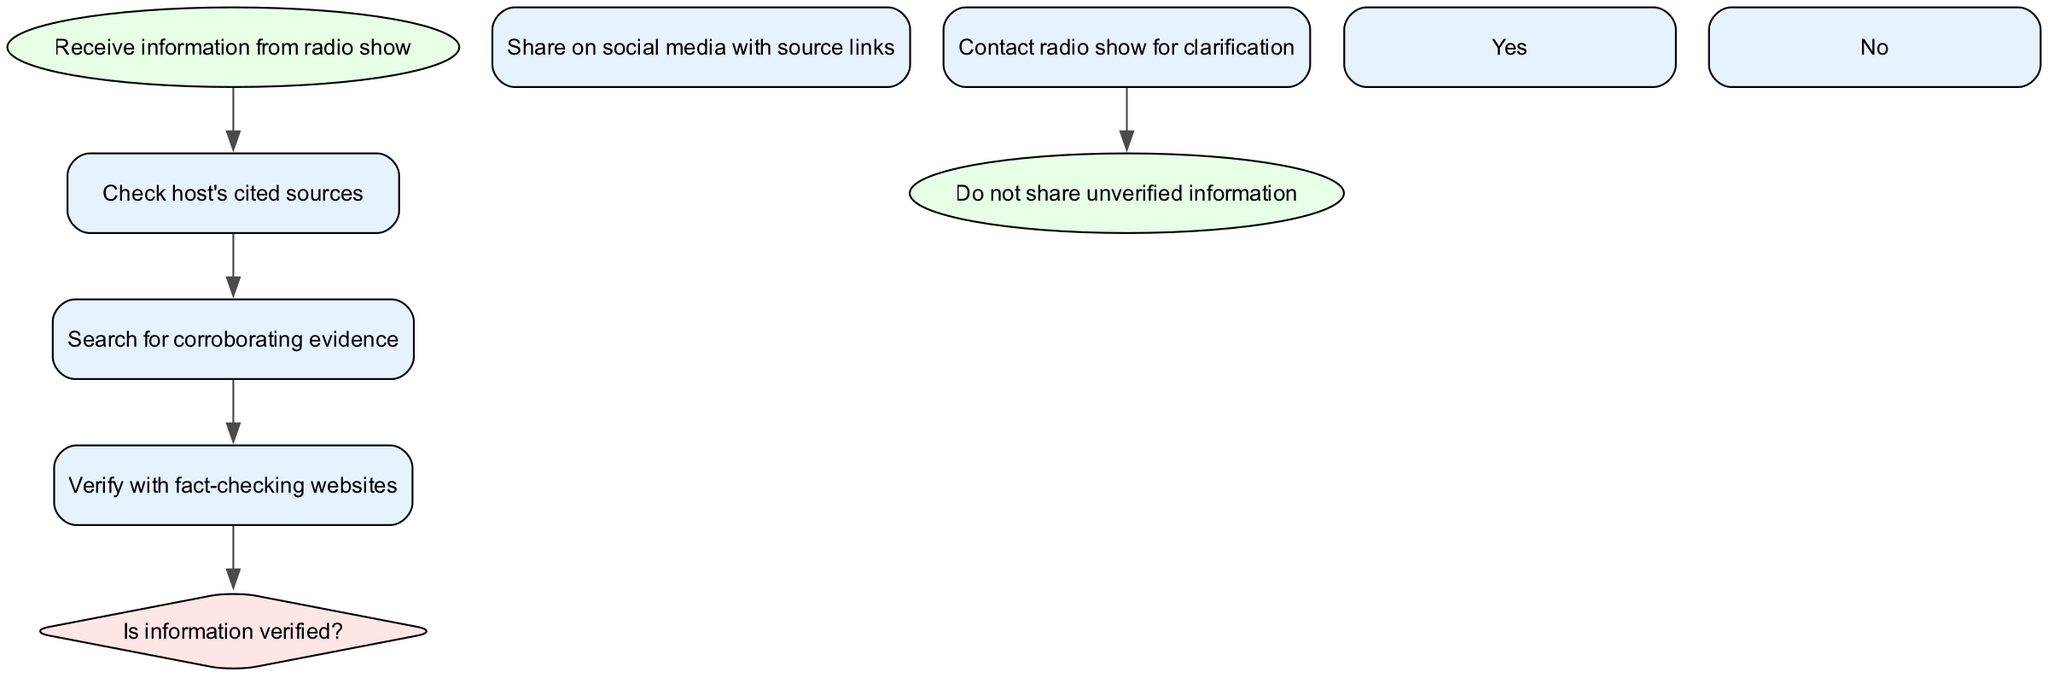What is the starting point of the process? The starting point is labeled 'Receive information from radio show,' which is the first node in the diagram.
Answer: Receive information from radio show What is the final action taken in this process? The final action represented in the diagram is 'Do not share unverified information,' which is shown in the last node.
Answer: Do not share unverified information How many decision points are present in the diagram? There is one decision point, indicated by the 'Is information verified?' diamond-shaped node.
Answer: One What is the action taken if the information is not verified? If the information is not verified, the next step is to 'Contact radio show for clarification,' as per the flow from the decision point labeled 'No.'
Answer: Contact radio show for clarification What are the two outcomes following the decision point? The two outcomes are 'Share on social media with source links' if verified, and 'Contact radio show for clarification' if not verified, as shown by the two edges leading from the decision node.
Answer: Share on social media with source links and Contact radio show for clarification What step comes after checking the host's cited sources? After checking the host's cited sources, the next step is 'Search for corroborating evidence,' as indicated by the edge connecting those two nodes.
Answer: Search for corroborating evidence Where does the flow go after verifying information with fact-checking websites? After verifying with fact-checking websites, the flow goes to the decision point labeled 'Is information verified?' where the next action is determined based on verification.
Answer: To the decision point 'Is information verified?' How many steps are there before reaching the decision point? There are three steps before reaching the decision point, as shown in the sequence of nodes from 'Check host's cited sources' to 'Verify with fact-checking websites.'
Answer: Three steps 